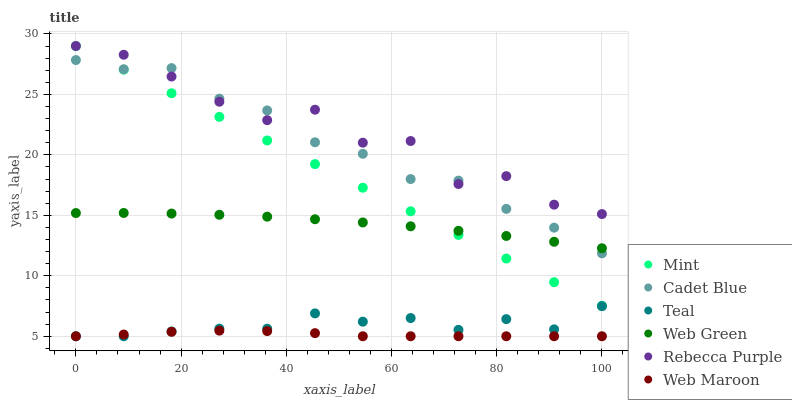Does Web Maroon have the minimum area under the curve?
Answer yes or no. Yes. Does Rebecca Purple have the maximum area under the curve?
Answer yes or no. Yes. Does Web Green have the minimum area under the curve?
Answer yes or no. No. Does Web Green have the maximum area under the curve?
Answer yes or no. No. Is Mint the smoothest?
Answer yes or no. Yes. Is Rebecca Purple the roughest?
Answer yes or no. Yes. Is Web Maroon the smoothest?
Answer yes or no. No. Is Web Maroon the roughest?
Answer yes or no. No. Does Web Maroon have the lowest value?
Answer yes or no. Yes. Does Web Green have the lowest value?
Answer yes or no. No. Does Mint have the highest value?
Answer yes or no. Yes. Does Web Green have the highest value?
Answer yes or no. No. Is Web Green less than Rebecca Purple?
Answer yes or no. Yes. Is Rebecca Purple greater than Web Maroon?
Answer yes or no. Yes. Does Rebecca Purple intersect Cadet Blue?
Answer yes or no. Yes. Is Rebecca Purple less than Cadet Blue?
Answer yes or no. No. Is Rebecca Purple greater than Cadet Blue?
Answer yes or no. No. Does Web Green intersect Rebecca Purple?
Answer yes or no. No. 